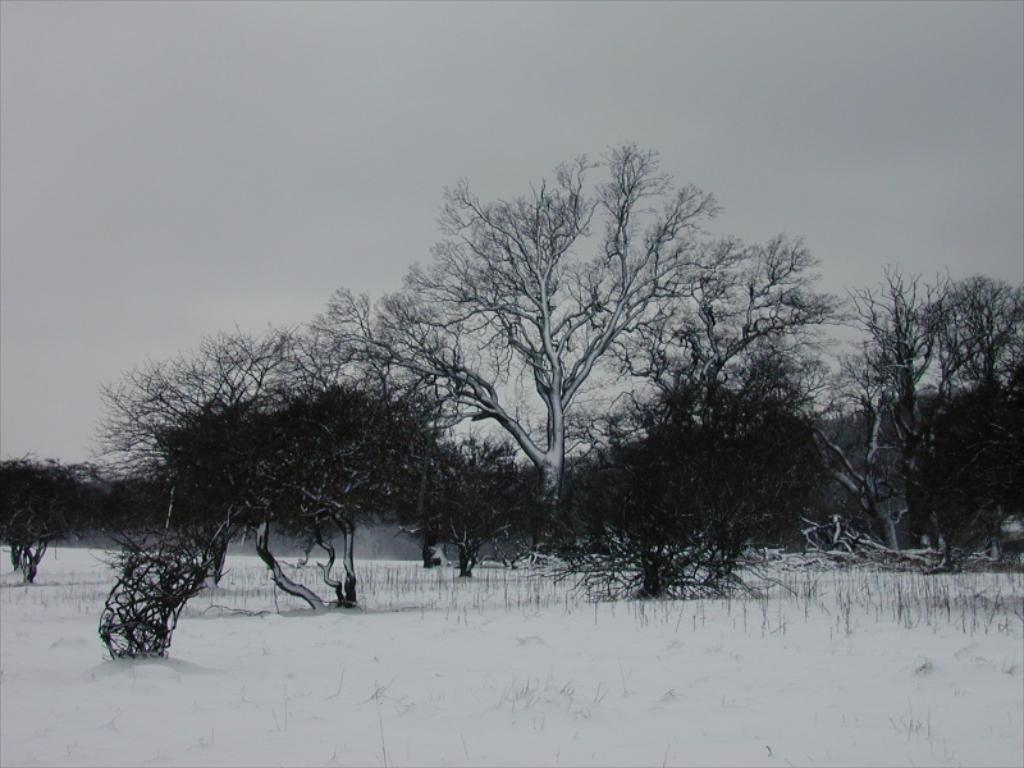What is the color scheme of the image? The image is black and white. What type of vegetation can be seen in the image? There is a group of trees in the image. What is covering the ground in the image? The ground is covered with snow in the image. What is visible in the background of the image? The sky is visible in the image. What is the weather condition suggested by the sky in the image? The sky looks cloudy in the image, suggesting a potentially overcast or snowy day. What brand of toothpaste is advertised on the trees in the image? There is no toothpaste or advertisement present in the image; it features a group of trees with snow on the ground and a cloudy sky. 